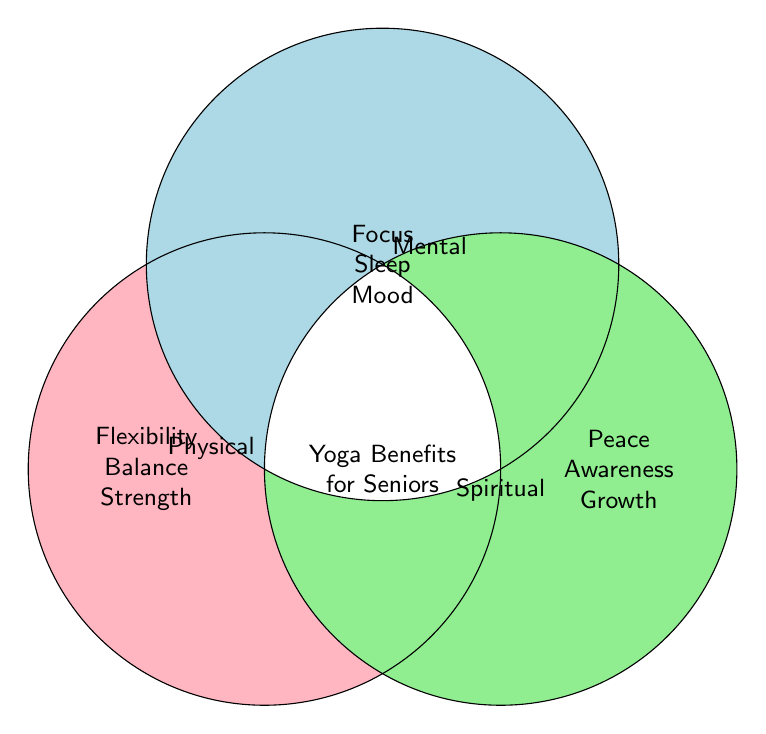What are the three main areas of benefits shown in the diagram? The diagram lists "Physical," "Mental," and "Spiritual" as the main categories of yoga benefits for seniors. These categories are labeled at the three points of the Venn diagram.
Answer: Physical, Mental, Spiritual What benefit is common to both the Physical and Mental areas? The benefits listed for both Physical and Mental areas overlap at some point in the middle. However, the diagram does not show an overlap between these two areas specifically in text.
Answer: None Which area does the benefit "Inner peace" fall under? "Inner peace" is listed under the Spiritual category, denoted by the label "Spiritual" at the corresponding circle.
Answer: Spiritual How many benefits are listed under each category? By counting the individual entries under each labeled section: Physical has 7, Mental has 7, and Spiritual has 7 benefits listed.
Answer: 7 each Which category includes benefits related to "Flexibility" and "Strength"? Both "Flexibility" and "Strength" are listed within the Physical benefits, which is visually distinct due to its unique color and position in the figure.
Answer: Physical What benefit overlaps in the Mental and Spiritual categories? To find common terms in the overlapping Mental and Spiritual benefits, observe both areas. Though there's no explicitly labeled overlap, a conceptual overlap of benefits can be inferred from "Focus" and "Mood."
Answer: Focus, Mood Where would you place "Better sleep"? "Better sleep" is listed under the Mental category according to the figure.
Answer: Mental Compare the number of benefits linked to improved mood between the Mental and Physical categories. "Mood elevation" appears under the Mental category; however, no benefits specifically mention mood under the Physical category.
Answer: Mental Identify a shared benefit that combines physical strength and spiritual growth. The benefits aligning with both physical strength (e.g., "Increased strength") and "Spiritual growth" are individually listed under Physical and Spiritual, yet not explicitly connected or overlapping in this Venn diagram.
Answer: None What's the benefit of "better balance" categorized under? "Better balance" is listed under the Physical category in the Venn diagram.
Answer: Physical 